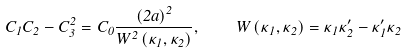Convert formula to latex. <formula><loc_0><loc_0><loc_500><loc_500>C _ { 1 } C _ { 2 } - C _ { 3 } ^ { 2 } = C _ { 0 } \frac { \left ( 2 a \right ) ^ { 2 } } { W ^ { 2 } \left ( \kappa _ { 1 } , \kappa _ { 2 } \right ) } , \quad W \left ( \kappa _ { 1 } , \kappa _ { 2 } \right ) = \kappa _ { 1 } \kappa _ { 2 } ^ { \prime } - \kappa _ { 1 } ^ { \prime } \kappa _ { 2 }</formula> 